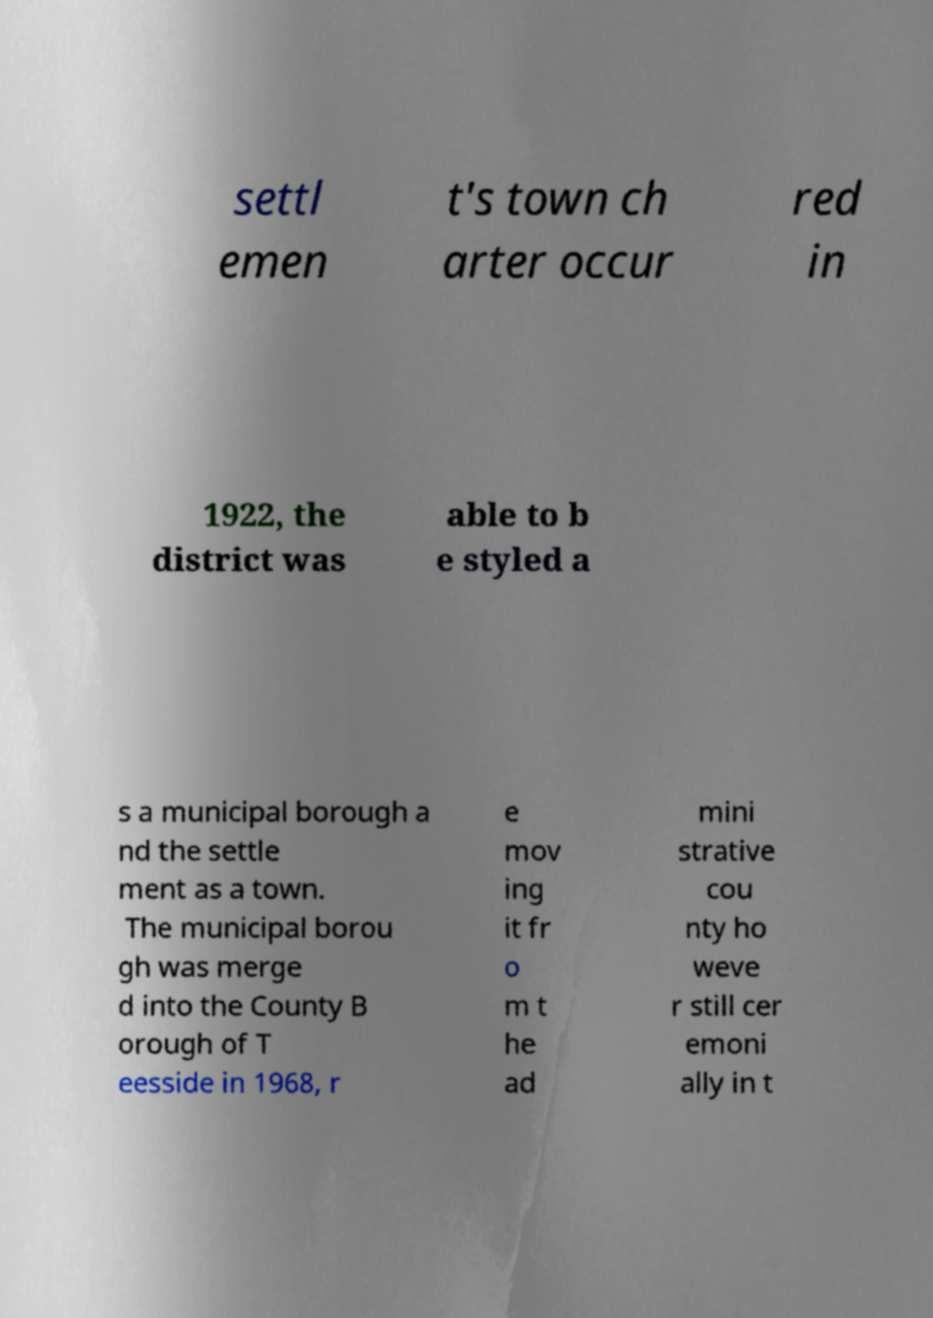I need the written content from this picture converted into text. Can you do that? settl emen t's town ch arter occur red in 1922, the district was able to b e styled a s a municipal borough a nd the settle ment as a town. The municipal borou gh was merge d into the County B orough of T eesside in 1968, r e mov ing it fr o m t he ad mini strative cou nty ho weve r still cer emoni ally in t 